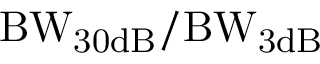<formula> <loc_0><loc_0><loc_500><loc_500>B W _ { 3 0 d B } / B W _ { 3 d B }</formula> 